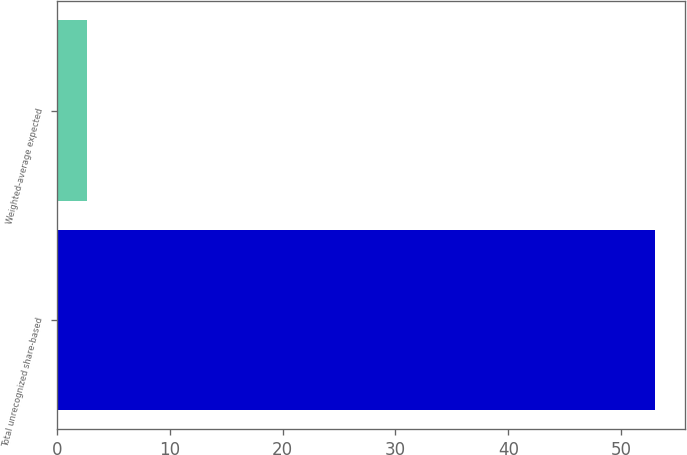Convert chart to OTSL. <chart><loc_0><loc_0><loc_500><loc_500><bar_chart><fcel>Total unrecognized share-based<fcel>Weighted-average expected<nl><fcel>53<fcel>2.7<nl></chart> 